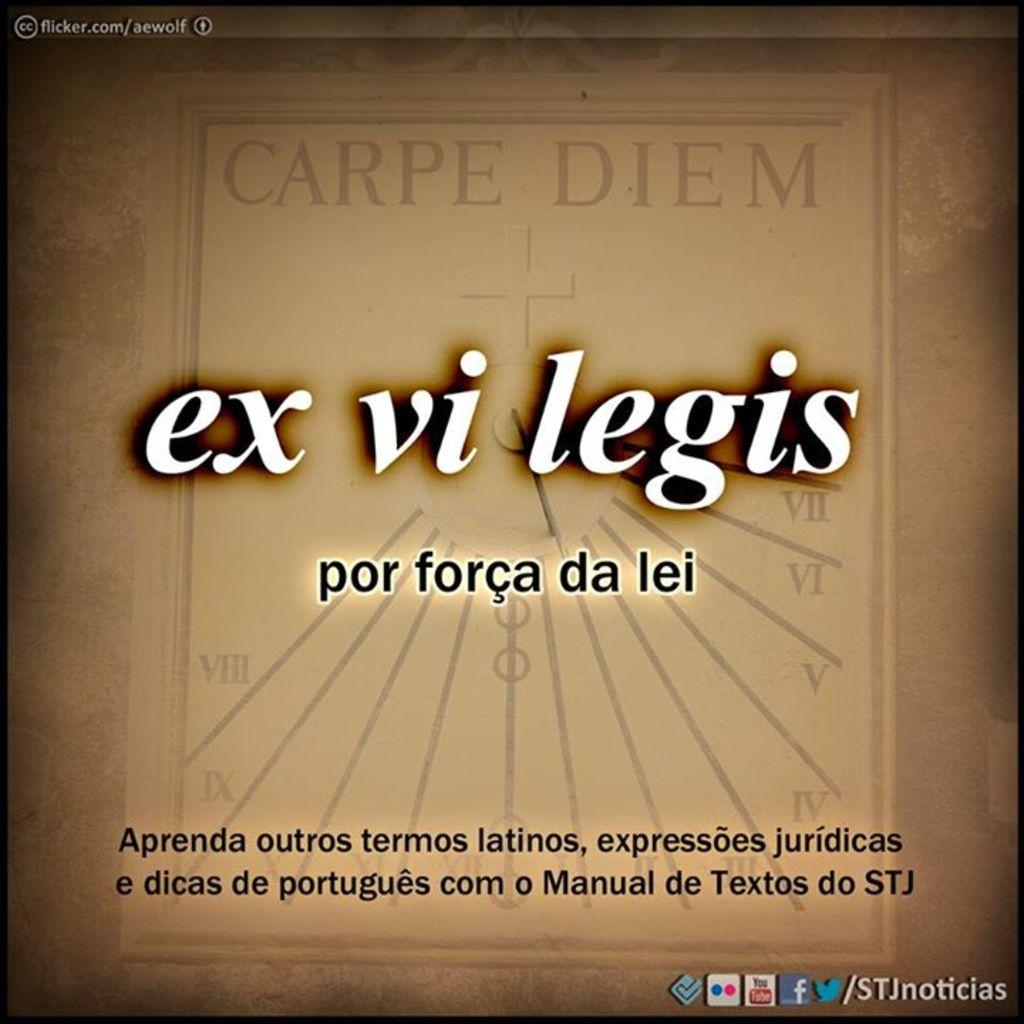<image>
Create a compact narrative representing the image presented. a sign reads Ex Vi Legis and Carpe Diem 